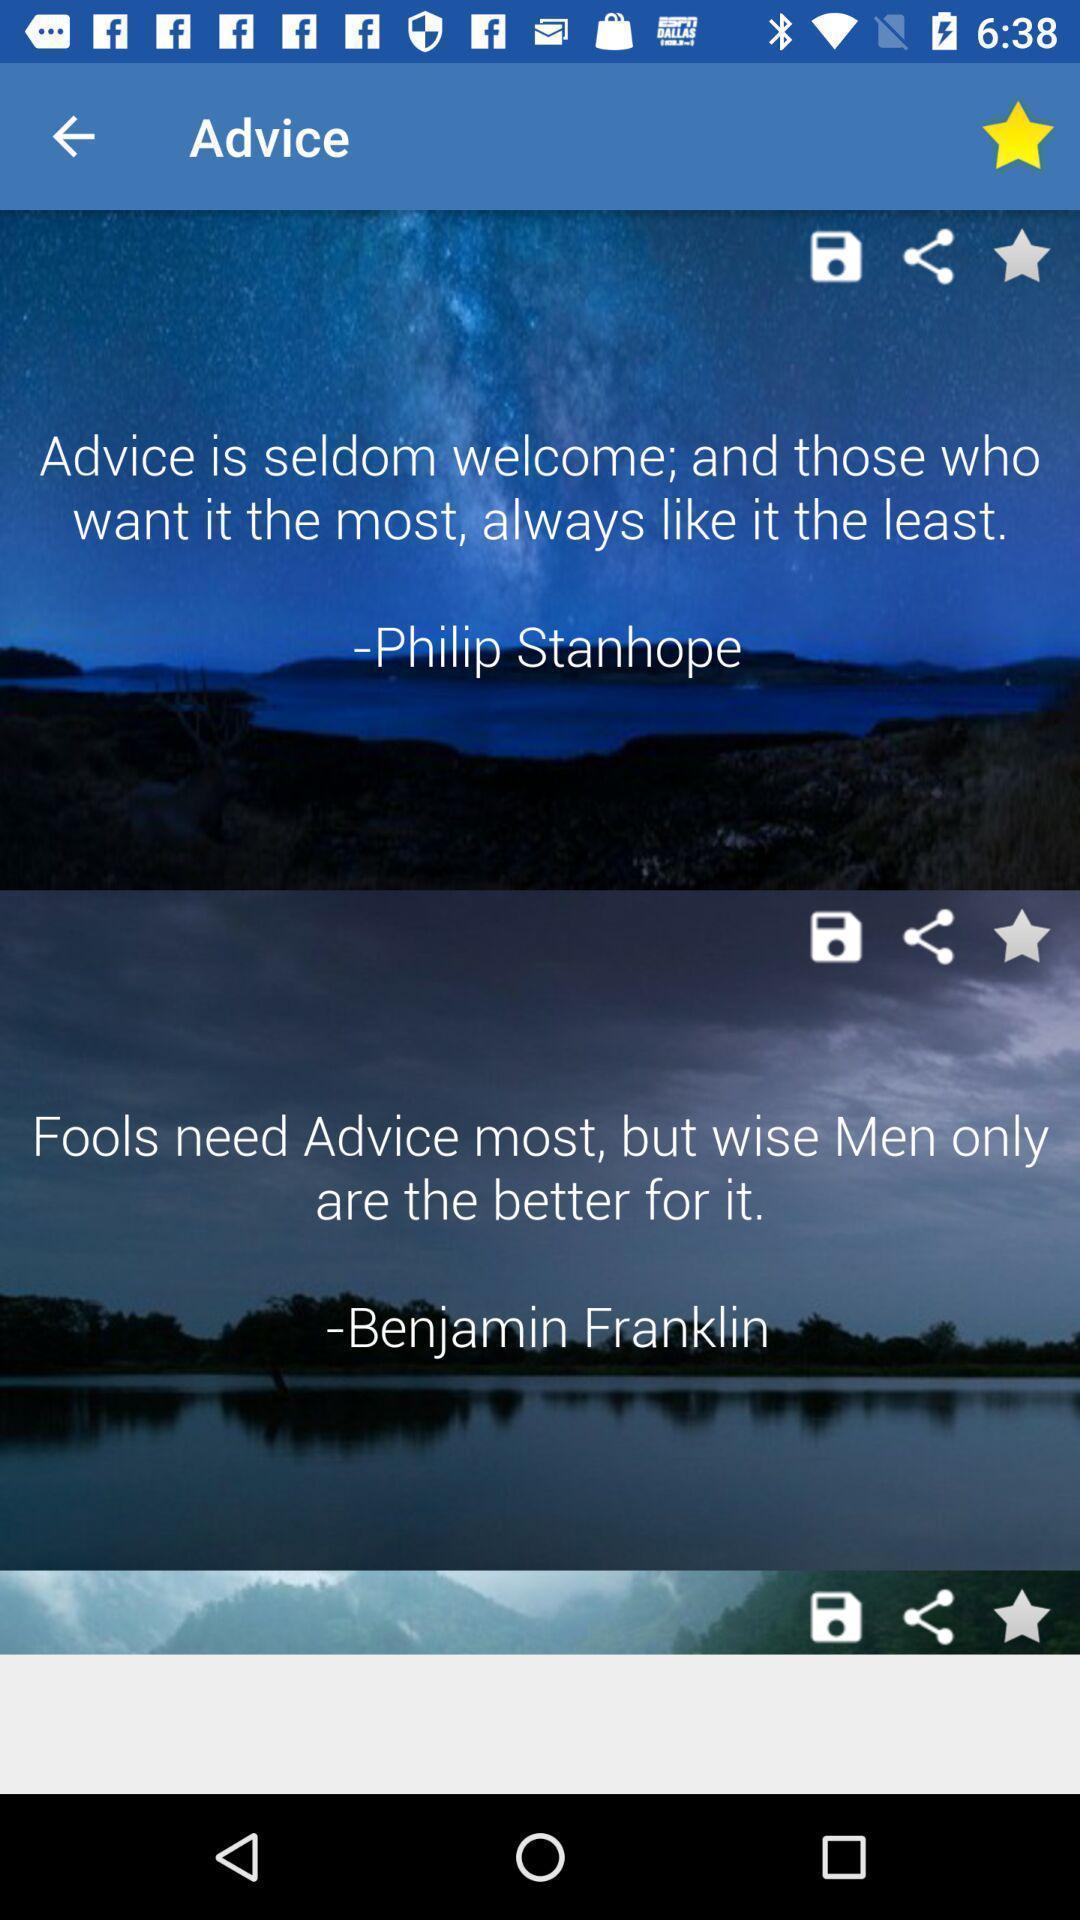Provide a textual representation of this image. Page showing the thumbnail with quotes. 